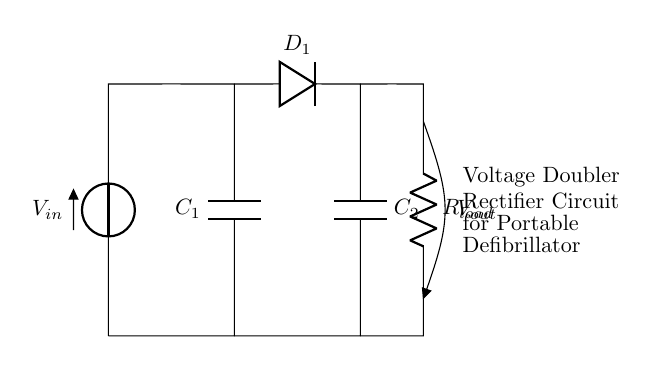What is the input voltage of this circuit? The circuit shows a voltage source labeled as V in. Therefore, the input voltage of the circuit is represented by this label.
Answer: V in What type of capacitors are used in this circuit? The components labeled C1 and C2 are capacitors according to the circuit diagram. Both are involved in the voltage doubling process.
Answer: Capacitors How many diodes are present in the circuit? By examining the circuit, only D1 is identified as a diode. Since it is the only one present, the total count is one.
Answer: One What is the purpose of the load resistor in this circuit? The resistor labeled R load serves to limit the current flowing to the load connected to the output. It dissipates the power and provides a path for current.
Answer: Current limiting What happens to the output voltage compared to the input voltage? The circuit is designed as a voltage doubler, meaning the output voltage (V out) is ideally double the input voltage (V in), provided the capacitors and diodes function correctly.
Answer: Doubled How does the capacitor affect rectification in this circuit? The capacitors (C1 and C2) store charge during the charging process, smoothing out the voltage and helping to produce a higher effective output voltage by discharging when the diode is forward-biased.
Answer: Charge storage What type of rectifier is implemented in this circuit? The circuit is specifically a voltage doubler rectifier circuit, combining the properties of capacitors and diodes to achieve higher output voltage from the input.
Answer: Voltage doubler rectifier 